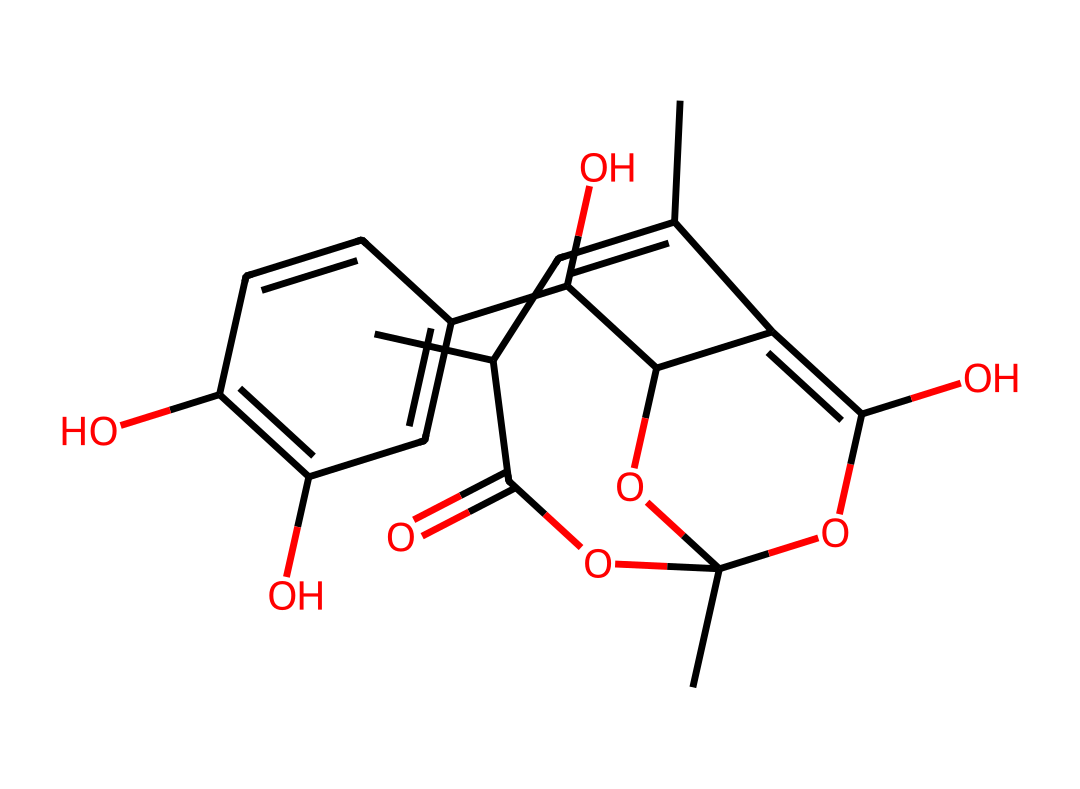What is the main functional group present in this chemical? The primary functional group in this chemical is an ester, characterized by the carbonyl (C=O) connected to an oxygen atom. The presence of the -COO- linkage in the structure indicates that it contains an ester functional group.
Answer: ester How many different types of atoms are present in this compound? By analyzing the SMILES representation, we can identify the distinct types of atoms: carbon (C), hydrogen (H), and oxygen (O). Counting each type gives us three unique atom types in total.
Answer: three What type of chemical compound is represented by this SMILES notation? The compound represented by this SMILES is a drug that is typically classified under natural products, specifically derived from plant sources and used traditionally in medicine. Its structure suggests it's a complex organic molecule with medicinal properties.
Answer: natural product How many hydroxyl groups (-OH) are observed in the structure? In the chemical structure, each -OH group is identified within the rings and branched portions. Counting the hydroxyl groups reveals that there are three -OH groups present in the molecule.
Answer: three What biological effect is kava primarily known for? Kava is well recognized for its anxiolytic (anti-anxiety) effects attributed to its active compounds. The structure suggests the presence of compounds that interact with GABA receptors, which is linked to its calming properties.
Answer: anxiolytic Which part of this chemical structure is likely responsible for its psychoactive effects? The psychoactive effects of kava are primarily associated with the kavalactones present in the molecule. These components interact with neurotransmitter systems, particularly affecting GABAergic activity.
Answer: kavalactones 